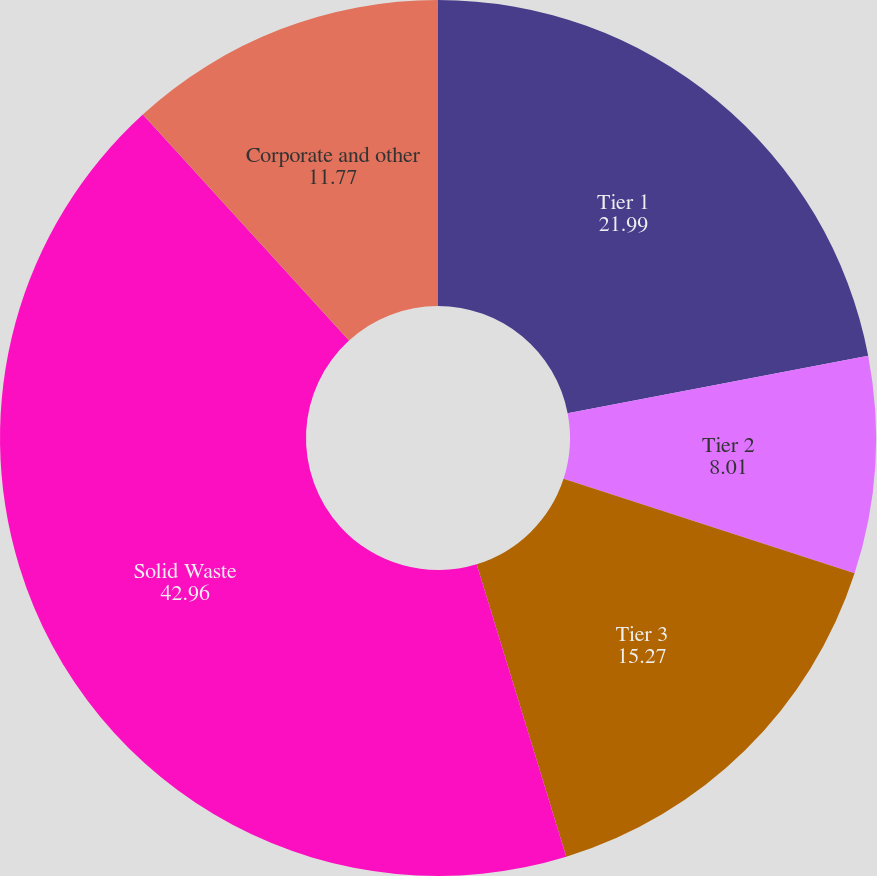<chart> <loc_0><loc_0><loc_500><loc_500><pie_chart><fcel>Tier 1<fcel>Tier 2<fcel>Tier 3<fcel>Solid Waste<fcel>Corporate and other<nl><fcel>21.99%<fcel>8.01%<fcel>15.27%<fcel>42.96%<fcel>11.77%<nl></chart> 